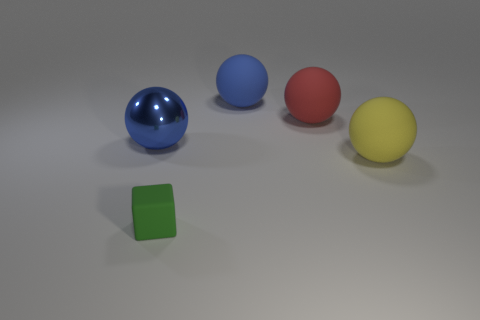Subtract all brown balls. Subtract all purple cubes. How many balls are left? 4 Add 1 large yellow rubber objects. How many objects exist? 6 Subtract all balls. How many objects are left? 1 Subtract 0 brown cylinders. How many objects are left? 5 Subtract all small green rubber cubes. Subtract all big blue matte objects. How many objects are left? 3 Add 5 big yellow balls. How many big yellow balls are left? 6 Add 4 green rubber cubes. How many green rubber cubes exist? 5 